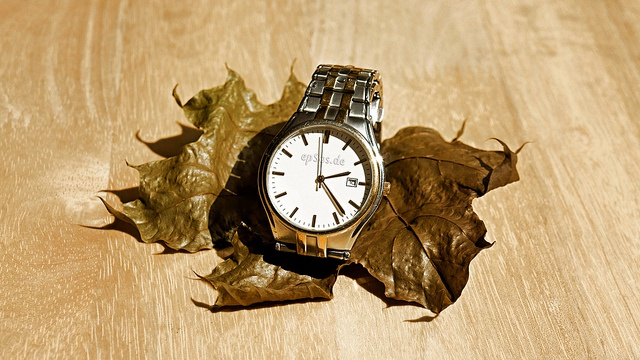Describe the objects in this image and their specific colors. I can see a clock in tan, white, olive, black, and maroon tones in this image. 